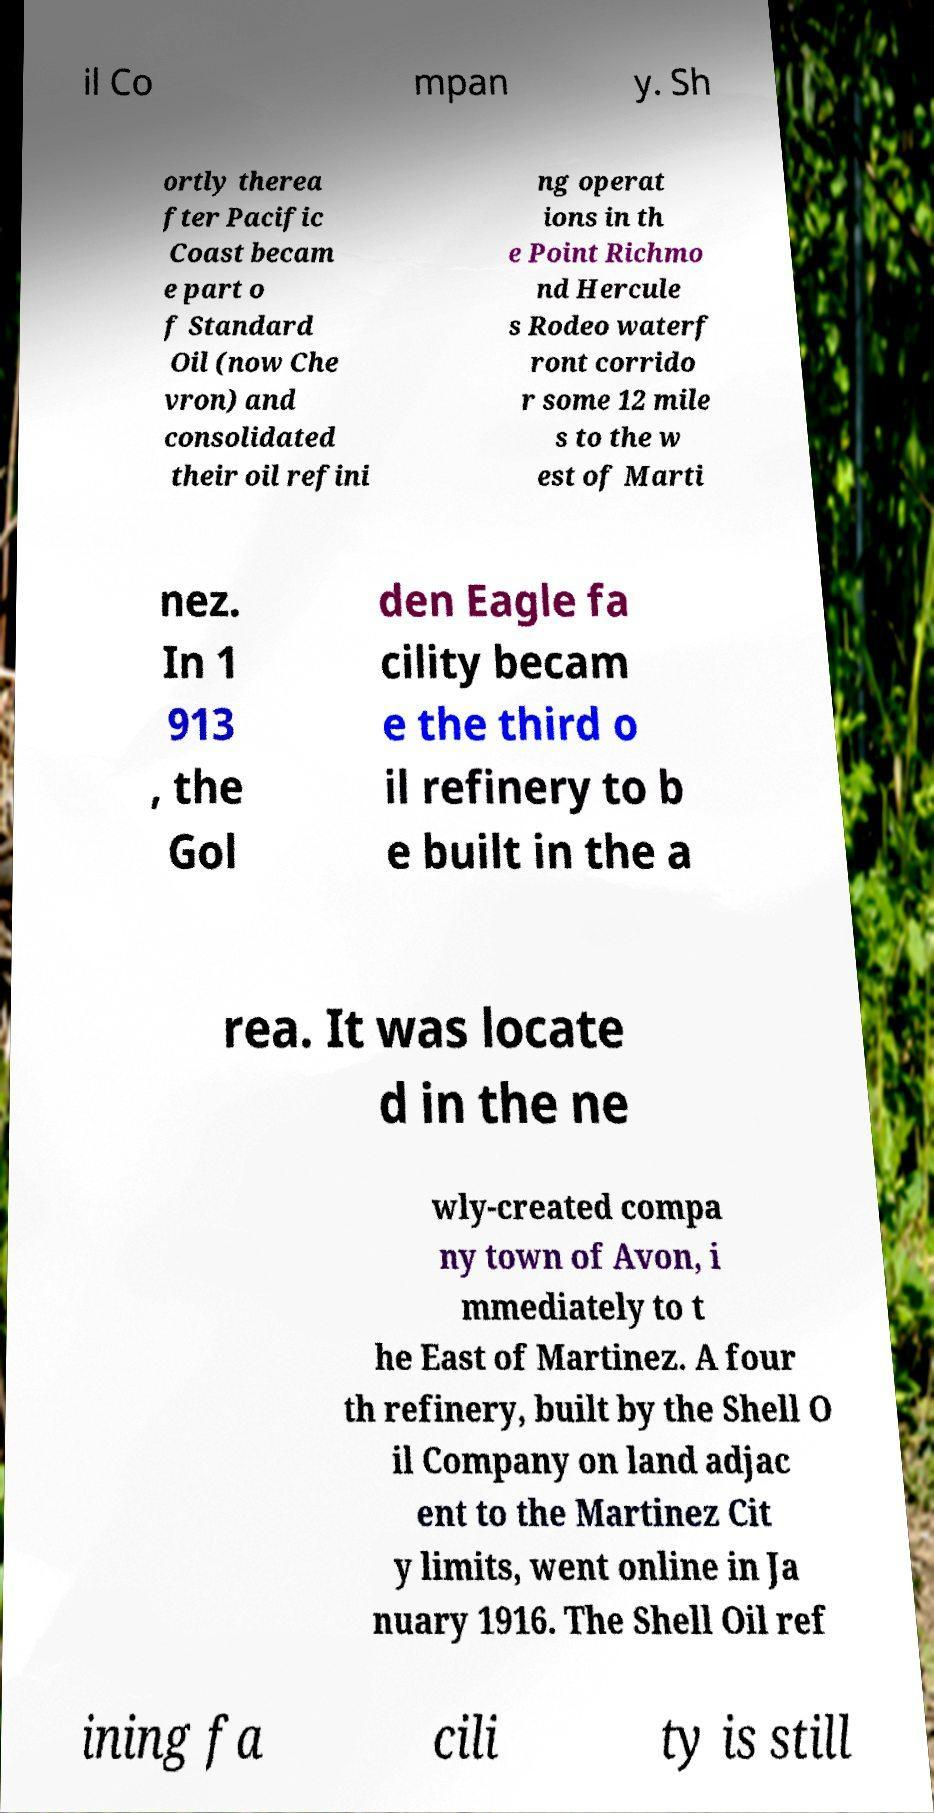Could you extract and type out the text from this image? il Co mpan y. Sh ortly therea fter Pacific Coast becam e part o f Standard Oil (now Che vron) and consolidated their oil refini ng operat ions in th e Point Richmo nd Hercule s Rodeo waterf ront corrido r some 12 mile s to the w est of Marti nez. In 1 913 , the Gol den Eagle fa cility becam e the third o il refinery to b e built in the a rea. It was locate d in the ne wly-created compa ny town of Avon, i mmediately to t he East of Martinez. A four th refinery, built by the Shell O il Company on land adjac ent to the Martinez Cit y limits, went online in Ja nuary 1916. The Shell Oil ref ining fa cili ty is still 